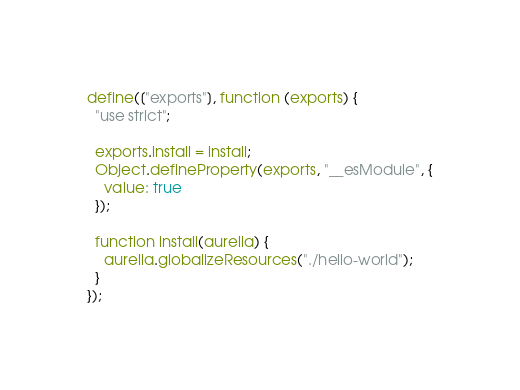Convert code to text. <code><loc_0><loc_0><loc_500><loc_500><_JavaScript_>define(["exports"], function (exports) {
  "use strict";

  exports.install = install;
  Object.defineProperty(exports, "__esModule", {
    value: true
  });

  function install(aurelia) {
    aurelia.globalizeResources("./hello-world");
  }
});</code> 